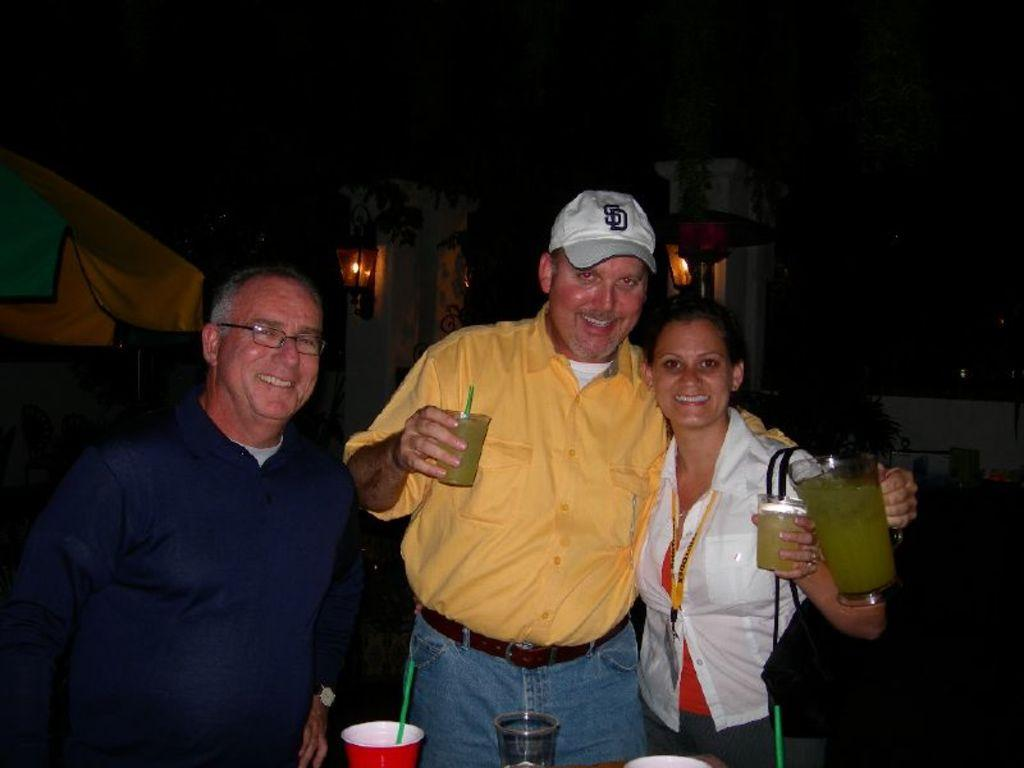<image>
Relay a brief, clear account of the picture shown. A man in a yellow shirt is wearing a white SD baseball cap. 